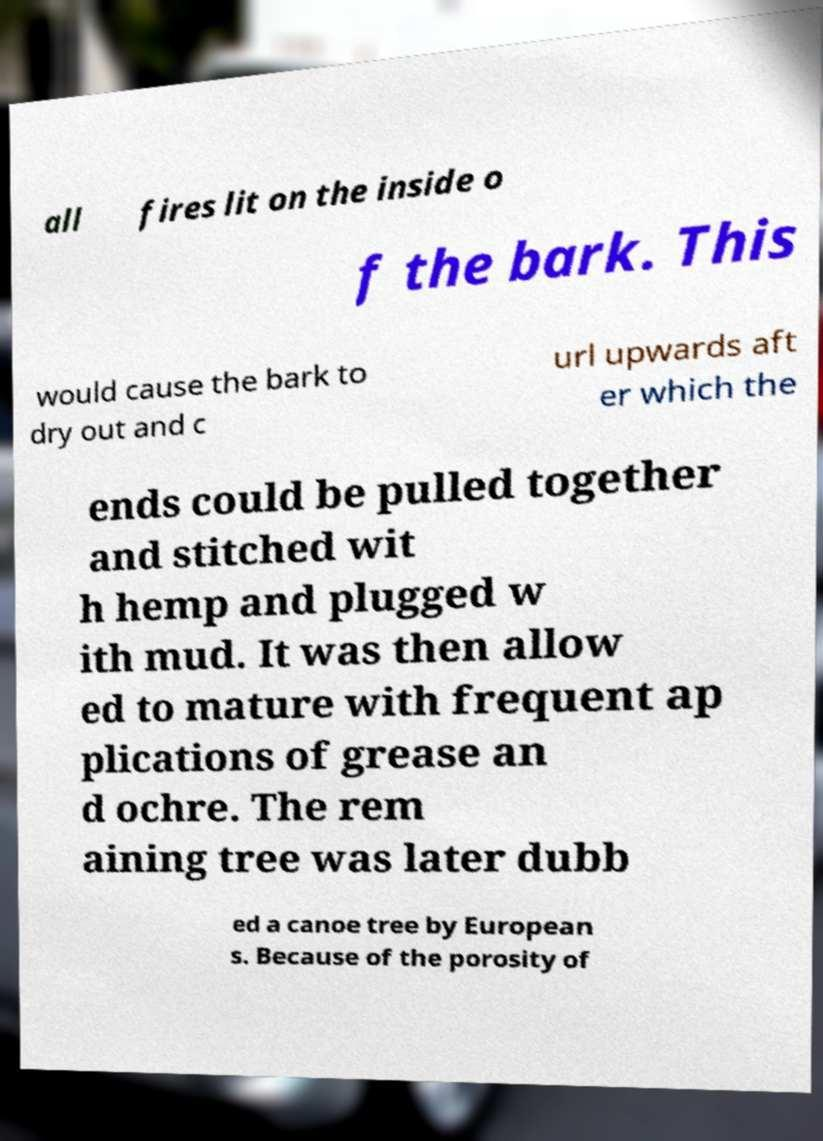Can you read and provide the text displayed in the image?This photo seems to have some interesting text. Can you extract and type it out for me? all fires lit on the inside o f the bark. This would cause the bark to dry out and c url upwards aft er which the ends could be pulled together and stitched wit h hemp and plugged w ith mud. It was then allow ed to mature with frequent ap plications of grease an d ochre. The rem aining tree was later dubb ed a canoe tree by European s. Because of the porosity of 